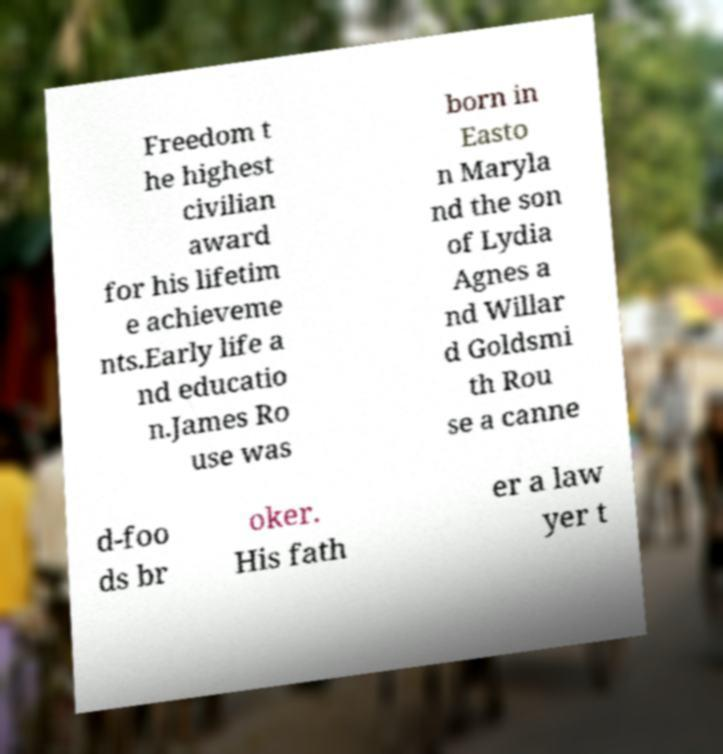Can you read and provide the text displayed in the image?This photo seems to have some interesting text. Can you extract and type it out for me? Freedom t he highest civilian award for his lifetim e achieveme nts.Early life a nd educatio n.James Ro use was born in Easto n Maryla nd the son of Lydia Agnes a nd Willar d Goldsmi th Rou se a canne d-foo ds br oker. His fath er a law yer t 